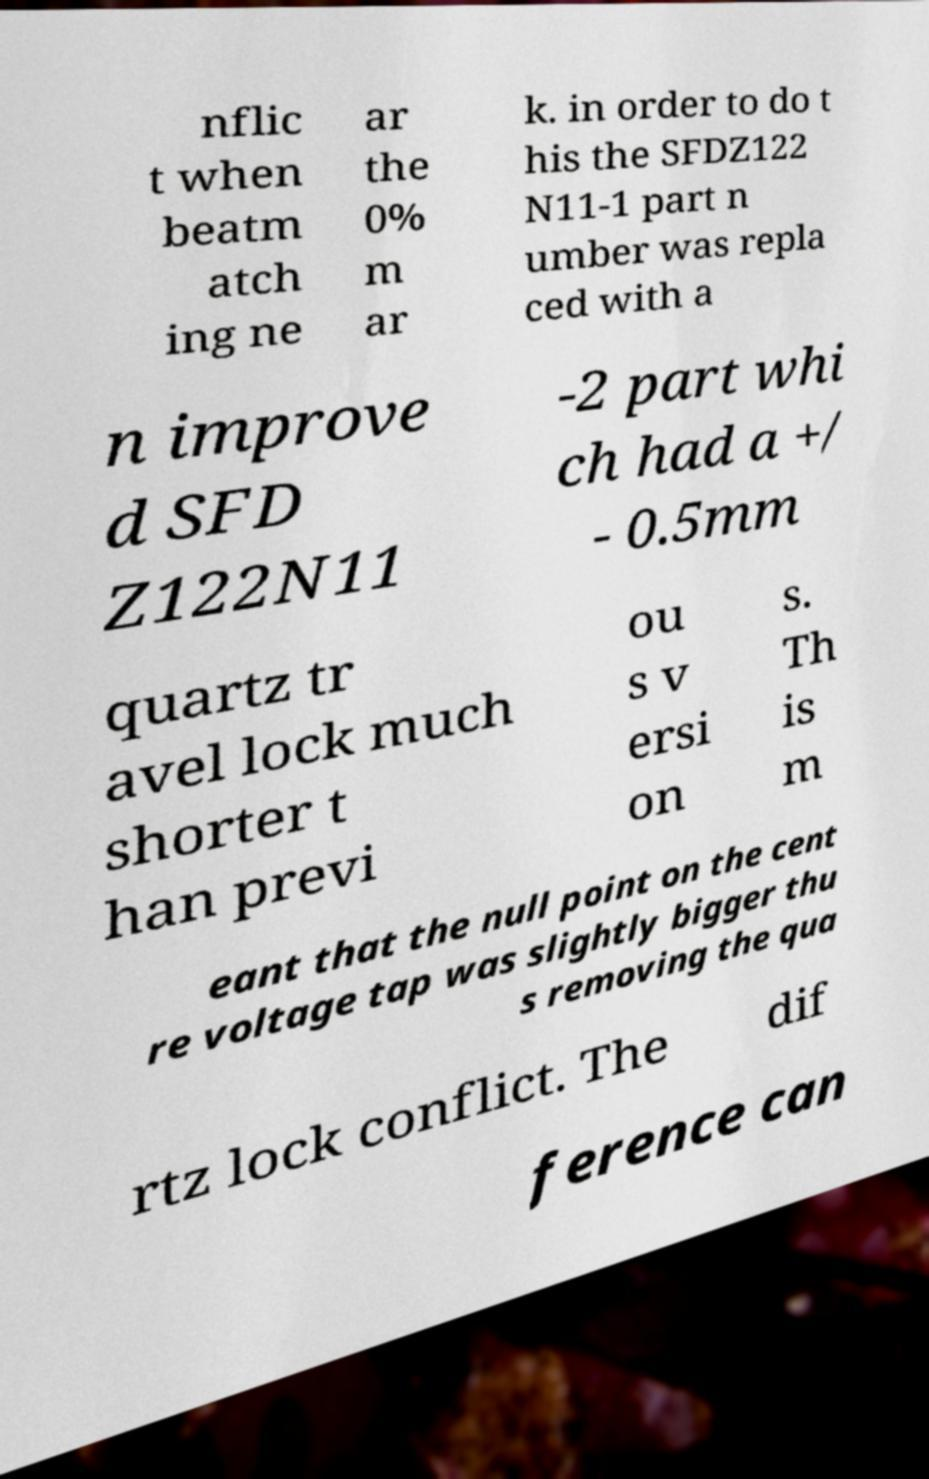Please read and relay the text visible in this image. What does it say? nflic t when beatm atch ing ne ar the 0% m ar k. in order to do t his the SFDZ122 N11-1 part n umber was repla ced with a n improve d SFD Z122N11 -2 part whi ch had a +/ - 0.5mm quartz tr avel lock much shorter t han previ ou s v ersi on s. Th is m eant that the null point on the cent re voltage tap was slightly bigger thu s removing the qua rtz lock conflict. The dif ference can 